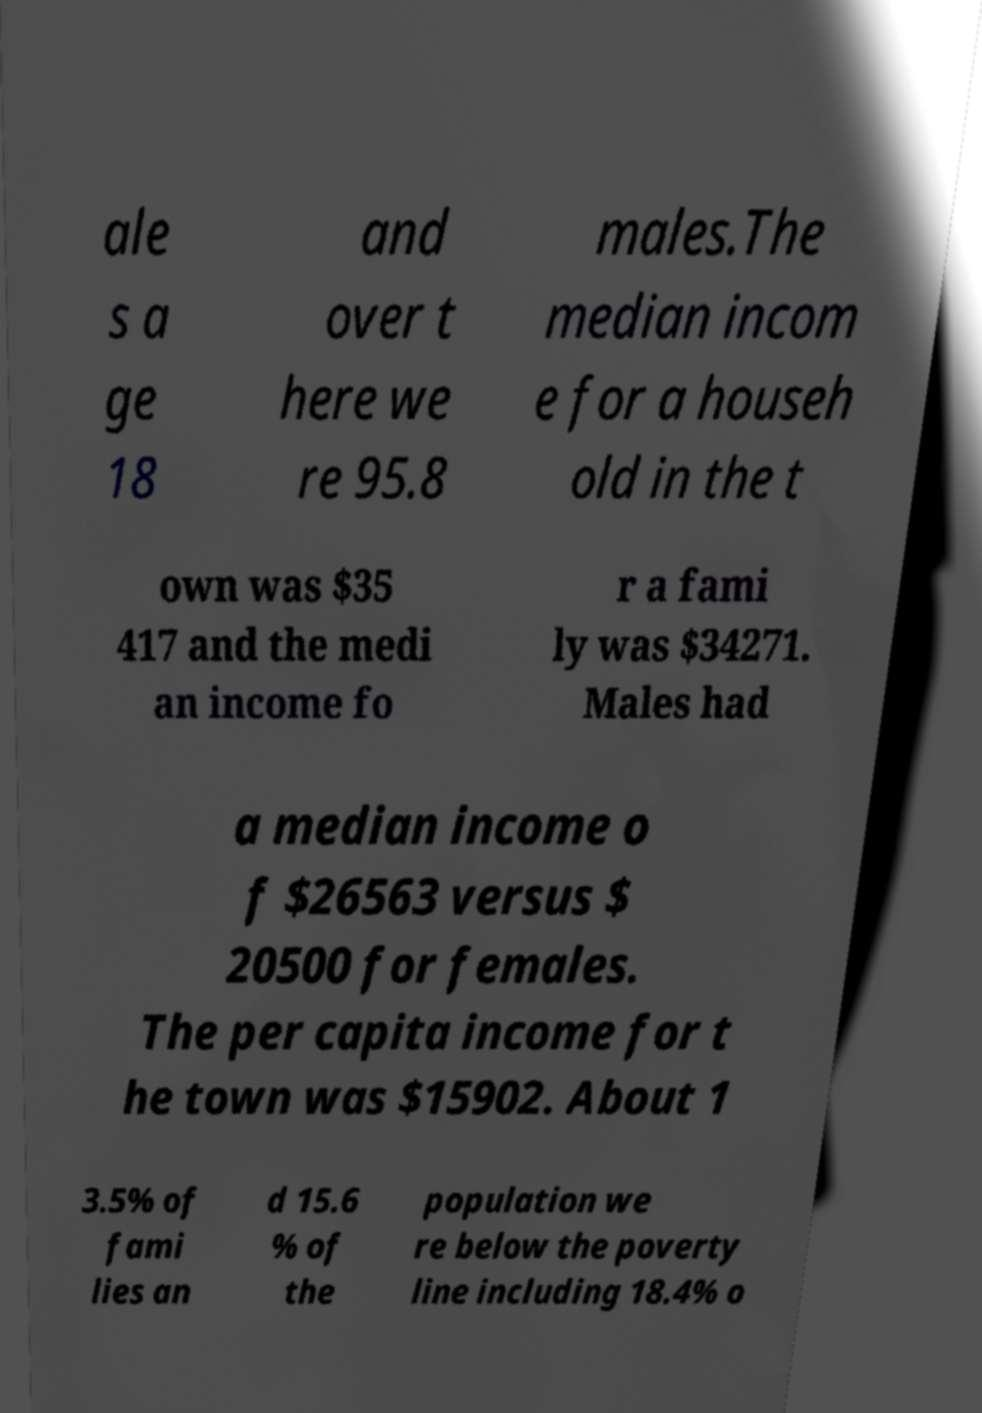Can you read and provide the text displayed in the image?This photo seems to have some interesting text. Can you extract and type it out for me? ale s a ge 18 and over t here we re 95.8 males.The median incom e for a househ old in the t own was $35 417 and the medi an income fo r a fami ly was $34271. Males had a median income o f $26563 versus $ 20500 for females. The per capita income for t he town was $15902. About 1 3.5% of fami lies an d 15.6 % of the population we re below the poverty line including 18.4% o 